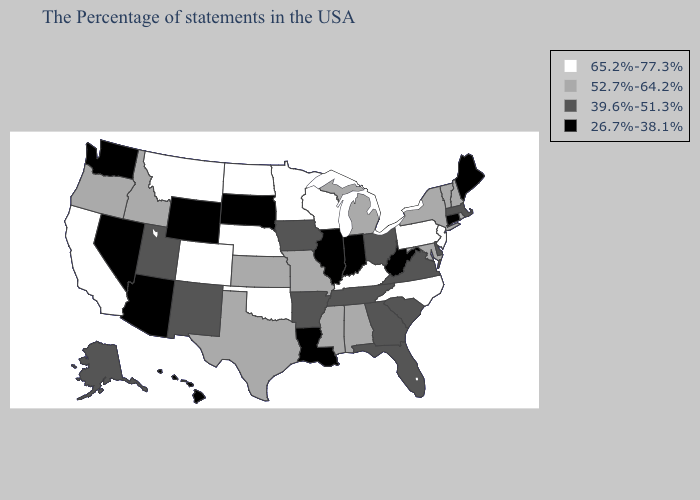What is the value of Pennsylvania?
Concise answer only. 65.2%-77.3%. Does New York have the same value as Illinois?
Write a very short answer. No. What is the value of Tennessee?
Keep it brief. 39.6%-51.3%. Name the states that have a value in the range 65.2%-77.3%?
Write a very short answer. New Jersey, Pennsylvania, North Carolina, Kentucky, Wisconsin, Minnesota, Nebraska, Oklahoma, North Dakota, Colorado, Montana, California. How many symbols are there in the legend?
Quick response, please. 4. What is the value of Kansas?
Short answer required. 52.7%-64.2%. Does the first symbol in the legend represent the smallest category?
Give a very brief answer. No. Does Texas have a lower value than Wisconsin?
Keep it brief. Yes. Name the states that have a value in the range 39.6%-51.3%?
Write a very short answer. Massachusetts, Delaware, Virginia, South Carolina, Ohio, Florida, Georgia, Tennessee, Arkansas, Iowa, New Mexico, Utah, Alaska. Among the states that border Montana , which have the lowest value?
Concise answer only. South Dakota, Wyoming. What is the value of Massachusetts?
Give a very brief answer. 39.6%-51.3%. Does the first symbol in the legend represent the smallest category?
Answer briefly. No. Name the states that have a value in the range 65.2%-77.3%?
Quick response, please. New Jersey, Pennsylvania, North Carolina, Kentucky, Wisconsin, Minnesota, Nebraska, Oklahoma, North Dakota, Colorado, Montana, California. Is the legend a continuous bar?
Write a very short answer. No. What is the value of Vermont?
Concise answer only. 52.7%-64.2%. 